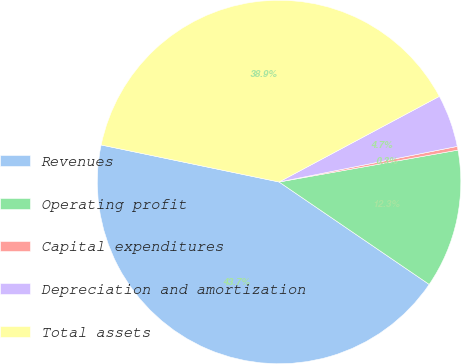<chart> <loc_0><loc_0><loc_500><loc_500><pie_chart><fcel>Revenues<fcel>Operating profit<fcel>Capital expenditures<fcel>Depreciation and amortization<fcel>Total assets<nl><fcel>43.74%<fcel>12.34%<fcel>0.33%<fcel>4.67%<fcel>38.93%<nl></chart> 